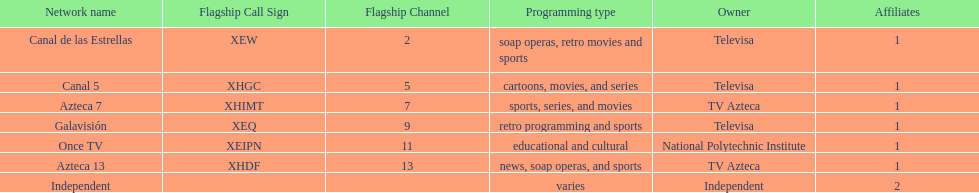Name a station that shows sports but is not televisa. Azteca 7. 